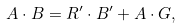<formula> <loc_0><loc_0><loc_500><loc_500>A \cdot B = R ^ { \prime } \cdot B ^ { \prime } + A \cdot G ,</formula> 